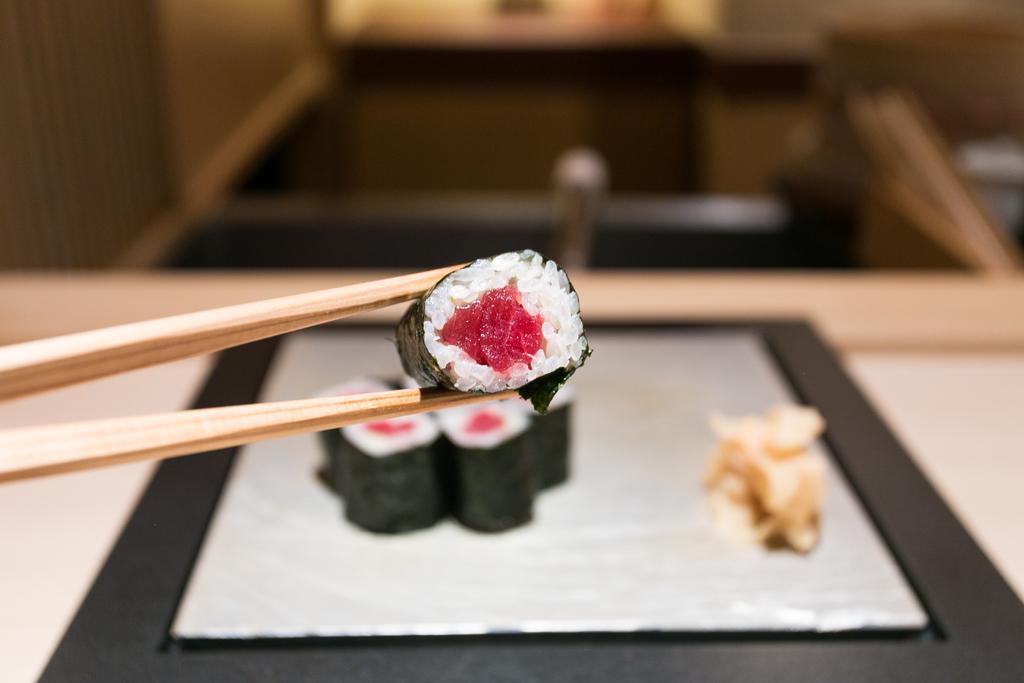In one or two sentences, can you explain what this image depicts? This picture shows there is a plate of food on it and there is a spoon with food in it. 